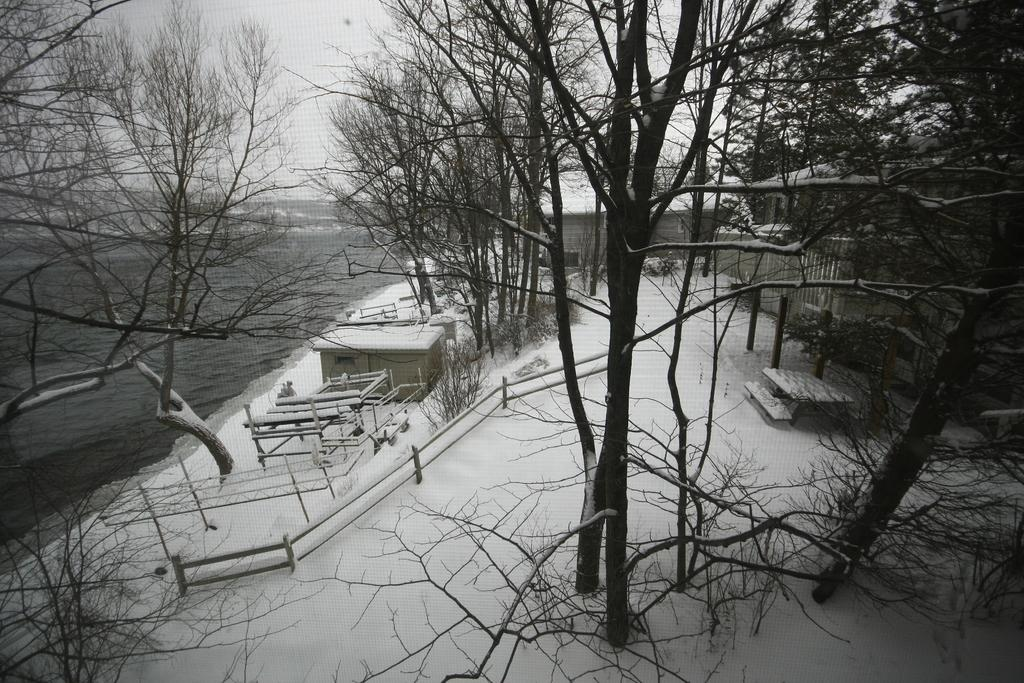What type of vegetation can be seen in the image? There are trees in the image. What type of structures are present in the image? There are buildings in the image. What is covering the ground in the image? There is snow on the ground in the image. What type of fork can be seen in the image? There is no fork present in the image. What is the current situation of the people in the image? There are no people visible in the image, so it is not possible to determine their current situation. 